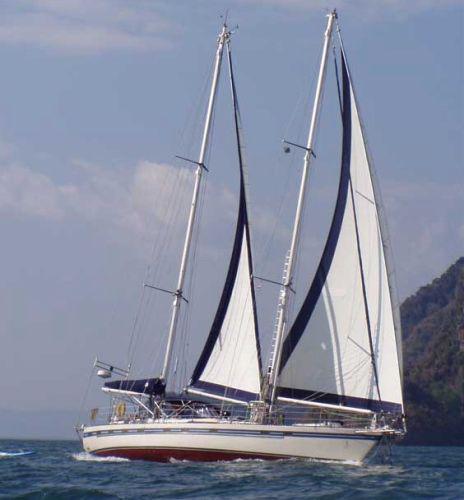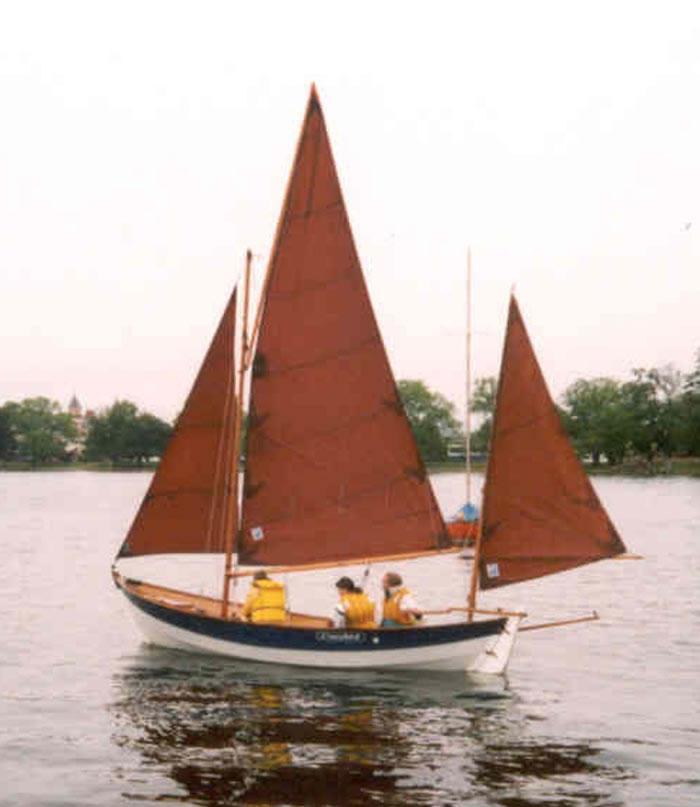The first image is the image on the left, the second image is the image on the right. Given the left and right images, does the statement "A total of one sailboat with brown sails is pictured." hold true? Answer yes or no. Yes. 